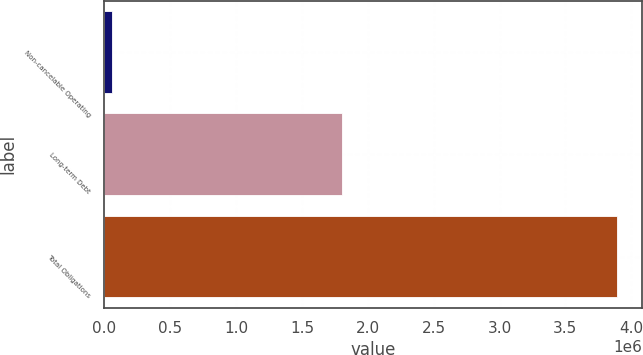Convert chart. <chart><loc_0><loc_0><loc_500><loc_500><bar_chart><fcel>Non-cancelable Operating<fcel>Long-term Debt<fcel>Total Obligations<nl><fcel>55580<fcel>1.80322e+06<fcel>3.8885e+06<nl></chart> 